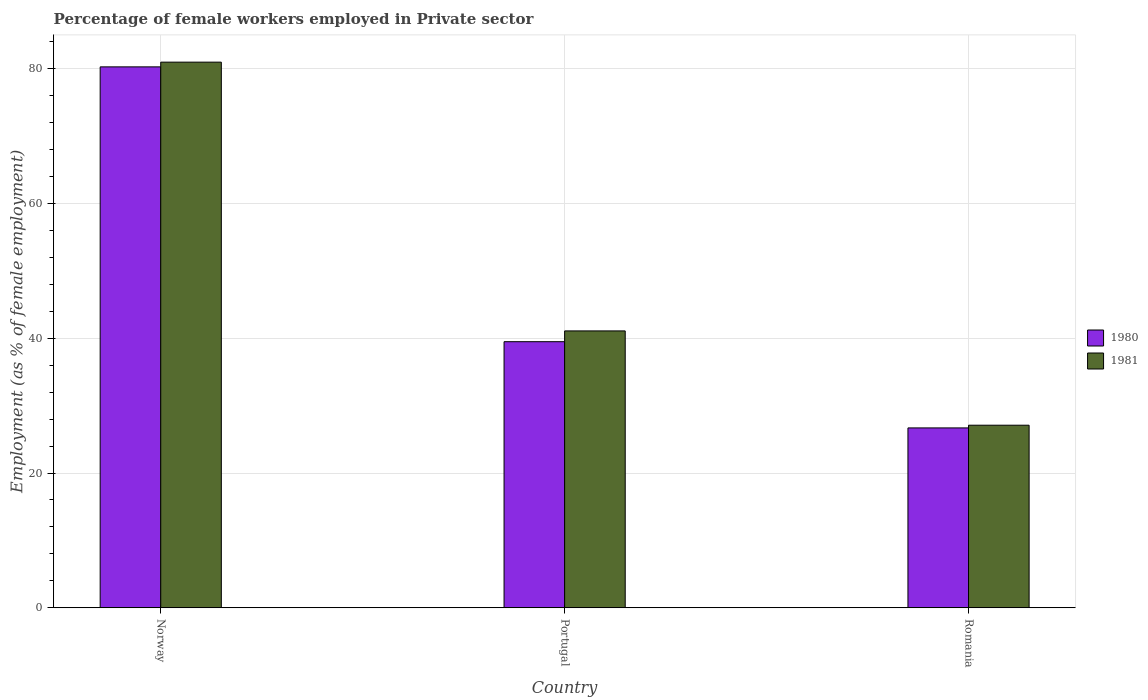How many different coloured bars are there?
Offer a terse response. 2. How many groups of bars are there?
Offer a very short reply. 3. How many bars are there on the 1st tick from the left?
Provide a short and direct response. 2. In how many cases, is the number of bars for a given country not equal to the number of legend labels?
Provide a short and direct response. 0. What is the percentage of females employed in Private sector in 1981 in Romania?
Ensure brevity in your answer.  27.1. Across all countries, what is the maximum percentage of females employed in Private sector in 1981?
Give a very brief answer. 81. Across all countries, what is the minimum percentage of females employed in Private sector in 1980?
Your response must be concise. 26.7. In which country was the percentage of females employed in Private sector in 1980 maximum?
Give a very brief answer. Norway. In which country was the percentage of females employed in Private sector in 1980 minimum?
Your response must be concise. Romania. What is the total percentage of females employed in Private sector in 1980 in the graph?
Provide a short and direct response. 146.5. What is the difference between the percentage of females employed in Private sector in 1981 in Norway and that in Romania?
Give a very brief answer. 53.9. What is the difference between the percentage of females employed in Private sector in 1980 in Norway and the percentage of females employed in Private sector in 1981 in Romania?
Offer a terse response. 53.2. What is the average percentage of females employed in Private sector in 1980 per country?
Provide a short and direct response. 48.83. What is the difference between the percentage of females employed in Private sector of/in 1980 and percentage of females employed in Private sector of/in 1981 in Norway?
Your answer should be compact. -0.7. What is the ratio of the percentage of females employed in Private sector in 1980 in Portugal to that in Romania?
Give a very brief answer. 1.48. What is the difference between the highest and the second highest percentage of females employed in Private sector in 1980?
Your response must be concise. 53.6. What is the difference between the highest and the lowest percentage of females employed in Private sector in 1981?
Provide a succinct answer. 53.9. What does the 1st bar from the left in Romania represents?
Provide a short and direct response. 1980. What does the 2nd bar from the right in Portugal represents?
Your response must be concise. 1980. How many bars are there?
Offer a very short reply. 6. Are all the bars in the graph horizontal?
Your response must be concise. No. What is the difference between two consecutive major ticks on the Y-axis?
Offer a terse response. 20. Does the graph contain any zero values?
Your answer should be compact. No. Does the graph contain grids?
Provide a succinct answer. Yes. Where does the legend appear in the graph?
Keep it short and to the point. Center right. How are the legend labels stacked?
Offer a terse response. Vertical. What is the title of the graph?
Make the answer very short. Percentage of female workers employed in Private sector. Does "1999" appear as one of the legend labels in the graph?
Provide a succinct answer. No. What is the label or title of the Y-axis?
Give a very brief answer. Employment (as % of female employment). What is the Employment (as % of female employment) in 1980 in Norway?
Your response must be concise. 80.3. What is the Employment (as % of female employment) in 1981 in Norway?
Your answer should be very brief. 81. What is the Employment (as % of female employment) of 1980 in Portugal?
Ensure brevity in your answer.  39.5. What is the Employment (as % of female employment) of 1981 in Portugal?
Ensure brevity in your answer.  41.1. What is the Employment (as % of female employment) in 1980 in Romania?
Offer a very short reply. 26.7. What is the Employment (as % of female employment) of 1981 in Romania?
Your response must be concise. 27.1. Across all countries, what is the maximum Employment (as % of female employment) of 1980?
Keep it short and to the point. 80.3. Across all countries, what is the minimum Employment (as % of female employment) in 1980?
Ensure brevity in your answer.  26.7. Across all countries, what is the minimum Employment (as % of female employment) in 1981?
Provide a succinct answer. 27.1. What is the total Employment (as % of female employment) in 1980 in the graph?
Provide a short and direct response. 146.5. What is the total Employment (as % of female employment) of 1981 in the graph?
Your response must be concise. 149.2. What is the difference between the Employment (as % of female employment) in 1980 in Norway and that in Portugal?
Provide a short and direct response. 40.8. What is the difference between the Employment (as % of female employment) of 1981 in Norway and that in Portugal?
Your answer should be very brief. 39.9. What is the difference between the Employment (as % of female employment) in 1980 in Norway and that in Romania?
Your response must be concise. 53.6. What is the difference between the Employment (as % of female employment) of 1981 in Norway and that in Romania?
Make the answer very short. 53.9. What is the difference between the Employment (as % of female employment) in 1981 in Portugal and that in Romania?
Ensure brevity in your answer.  14. What is the difference between the Employment (as % of female employment) of 1980 in Norway and the Employment (as % of female employment) of 1981 in Portugal?
Your answer should be compact. 39.2. What is the difference between the Employment (as % of female employment) of 1980 in Norway and the Employment (as % of female employment) of 1981 in Romania?
Ensure brevity in your answer.  53.2. What is the difference between the Employment (as % of female employment) of 1980 in Portugal and the Employment (as % of female employment) of 1981 in Romania?
Make the answer very short. 12.4. What is the average Employment (as % of female employment) in 1980 per country?
Your answer should be very brief. 48.83. What is the average Employment (as % of female employment) in 1981 per country?
Keep it short and to the point. 49.73. What is the difference between the Employment (as % of female employment) of 1980 and Employment (as % of female employment) of 1981 in Romania?
Make the answer very short. -0.4. What is the ratio of the Employment (as % of female employment) of 1980 in Norway to that in Portugal?
Provide a succinct answer. 2.03. What is the ratio of the Employment (as % of female employment) of 1981 in Norway to that in Portugal?
Offer a terse response. 1.97. What is the ratio of the Employment (as % of female employment) in 1980 in Norway to that in Romania?
Provide a short and direct response. 3.01. What is the ratio of the Employment (as % of female employment) of 1981 in Norway to that in Romania?
Your response must be concise. 2.99. What is the ratio of the Employment (as % of female employment) in 1980 in Portugal to that in Romania?
Your answer should be very brief. 1.48. What is the ratio of the Employment (as % of female employment) in 1981 in Portugal to that in Romania?
Offer a very short reply. 1.52. What is the difference between the highest and the second highest Employment (as % of female employment) in 1980?
Keep it short and to the point. 40.8. What is the difference between the highest and the second highest Employment (as % of female employment) of 1981?
Your response must be concise. 39.9. What is the difference between the highest and the lowest Employment (as % of female employment) of 1980?
Give a very brief answer. 53.6. What is the difference between the highest and the lowest Employment (as % of female employment) in 1981?
Make the answer very short. 53.9. 